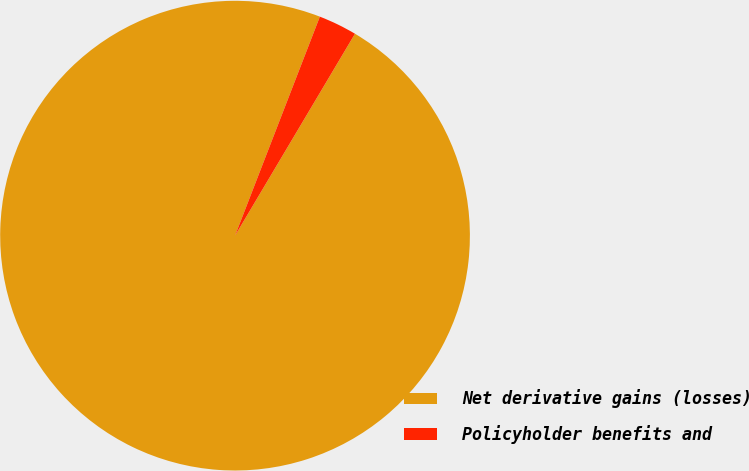Convert chart. <chart><loc_0><loc_0><loc_500><loc_500><pie_chart><fcel>Net derivative gains (losses)<fcel>Policyholder benefits and<nl><fcel>97.35%<fcel>2.65%<nl></chart> 